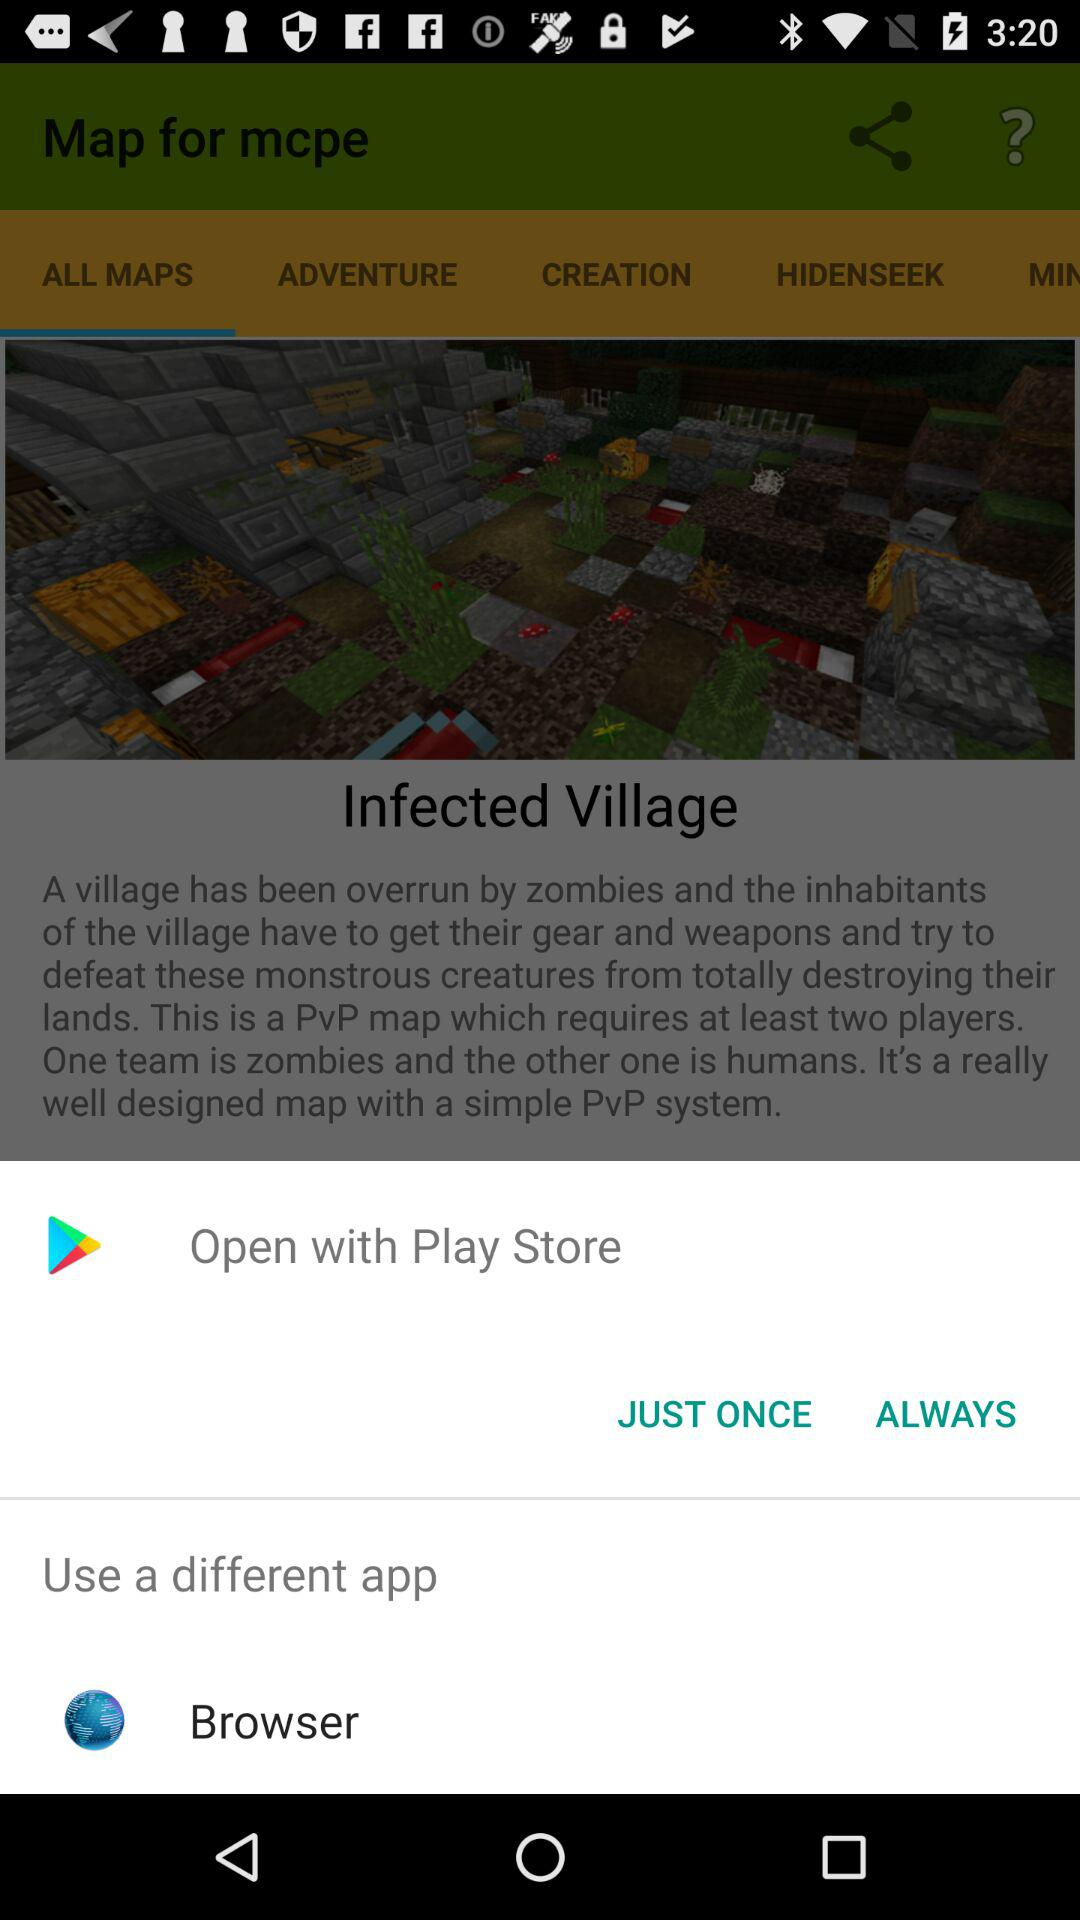What are the apps that may be used to open the maps? The apps that can be used to open the maps are "Play Store" and "Browser". 